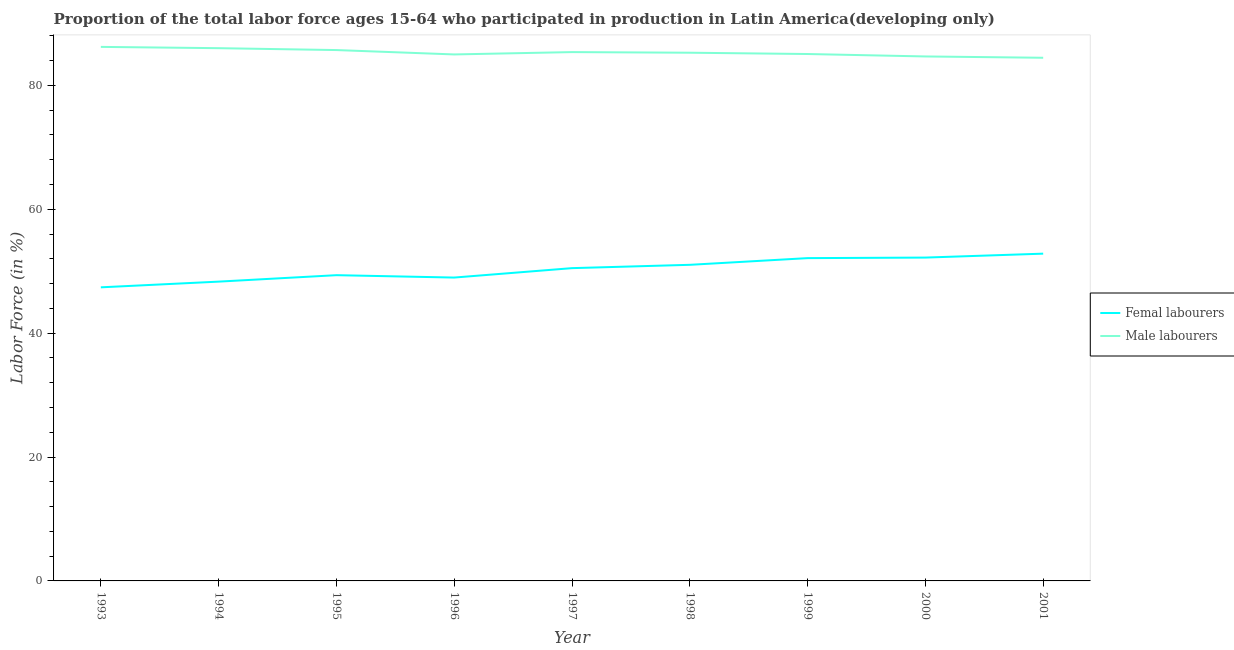How many different coloured lines are there?
Your answer should be very brief. 2. Is the number of lines equal to the number of legend labels?
Give a very brief answer. Yes. What is the percentage of male labour force in 2000?
Offer a very short reply. 84.67. Across all years, what is the maximum percentage of male labour force?
Your response must be concise. 86.21. Across all years, what is the minimum percentage of male labour force?
Ensure brevity in your answer.  84.46. What is the total percentage of female labor force in the graph?
Make the answer very short. 452.73. What is the difference between the percentage of female labor force in 1996 and that in 1998?
Your answer should be very brief. -2.06. What is the difference between the percentage of female labor force in 1998 and the percentage of male labour force in 2000?
Ensure brevity in your answer.  -33.64. What is the average percentage of male labour force per year?
Keep it short and to the point. 85.31. In the year 2001, what is the difference between the percentage of male labour force and percentage of female labor force?
Offer a very short reply. 31.62. In how many years, is the percentage of female labor force greater than 48 %?
Provide a short and direct response. 8. What is the ratio of the percentage of male labour force in 1996 to that in 1997?
Your answer should be very brief. 1. Is the difference between the percentage of female labor force in 1997 and 2001 greater than the difference between the percentage of male labour force in 1997 and 2001?
Your answer should be compact. No. What is the difference between the highest and the second highest percentage of male labour force?
Provide a succinct answer. 0.21. What is the difference between the highest and the lowest percentage of female labor force?
Provide a succinct answer. 5.44. Does the percentage of female labor force monotonically increase over the years?
Provide a short and direct response. No. Is the percentage of female labor force strictly less than the percentage of male labour force over the years?
Make the answer very short. Yes. Does the graph contain any zero values?
Your answer should be very brief. No. Does the graph contain grids?
Offer a very short reply. No. Where does the legend appear in the graph?
Keep it short and to the point. Center right. How are the legend labels stacked?
Your answer should be compact. Vertical. What is the title of the graph?
Ensure brevity in your answer.  Proportion of the total labor force ages 15-64 who participated in production in Latin America(developing only). Does "Export" appear as one of the legend labels in the graph?
Provide a short and direct response. No. What is the label or title of the X-axis?
Make the answer very short. Year. What is the Labor Force (in %) of Femal labourers in 1993?
Offer a terse response. 47.4. What is the Labor Force (in %) of Male labourers in 1993?
Provide a succinct answer. 86.21. What is the Labor Force (in %) of Femal labourers in 1994?
Offer a very short reply. 48.32. What is the Labor Force (in %) in Male labourers in 1994?
Provide a short and direct response. 86.01. What is the Labor Force (in %) of Femal labourers in 1995?
Your answer should be compact. 49.36. What is the Labor Force (in %) in Male labourers in 1995?
Offer a very short reply. 85.7. What is the Labor Force (in %) of Femal labourers in 1996?
Offer a very short reply. 48.98. What is the Labor Force (in %) of Male labourers in 1996?
Your answer should be compact. 85. What is the Labor Force (in %) in Femal labourers in 1997?
Provide a succinct answer. 50.5. What is the Labor Force (in %) in Male labourers in 1997?
Keep it short and to the point. 85.37. What is the Labor Force (in %) of Femal labourers in 1998?
Give a very brief answer. 51.03. What is the Labor Force (in %) in Male labourers in 1998?
Offer a terse response. 85.28. What is the Labor Force (in %) of Femal labourers in 1999?
Your answer should be compact. 52.11. What is the Labor Force (in %) in Male labourers in 1999?
Provide a succinct answer. 85.06. What is the Labor Force (in %) in Femal labourers in 2000?
Give a very brief answer. 52.2. What is the Labor Force (in %) in Male labourers in 2000?
Your response must be concise. 84.67. What is the Labor Force (in %) of Femal labourers in 2001?
Your response must be concise. 52.83. What is the Labor Force (in %) of Male labourers in 2001?
Your answer should be compact. 84.46. Across all years, what is the maximum Labor Force (in %) of Femal labourers?
Provide a short and direct response. 52.83. Across all years, what is the maximum Labor Force (in %) in Male labourers?
Provide a short and direct response. 86.21. Across all years, what is the minimum Labor Force (in %) in Femal labourers?
Offer a very short reply. 47.4. Across all years, what is the minimum Labor Force (in %) of Male labourers?
Offer a very short reply. 84.46. What is the total Labor Force (in %) in Femal labourers in the graph?
Your answer should be very brief. 452.73. What is the total Labor Force (in %) in Male labourers in the graph?
Your response must be concise. 767.77. What is the difference between the Labor Force (in %) in Femal labourers in 1993 and that in 1994?
Ensure brevity in your answer.  -0.92. What is the difference between the Labor Force (in %) in Male labourers in 1993 and that in 1994?
Your response must be concise. 0.21. What is the difference between the Labor Force (in %) in Femal labourers in 1993 and that in 1995?
Provide a succinct answer. -1.96. What is the difference between the Labor Force (in %) of Male labourers in 1993 and that in 1995?
Provide a short and direct response. 0.51. What is the difference between the Labor Force (in %) of Femal labourers in 1993 and that in 1996?
Offer a very short reply. -1.58. What is the difference between the Labor Force (in %) in Male labourers in 1993 and that in 1996?
Offer a very short reply. 1.22. What is the difference between the Labor Force (in %) of Femal labourers in 1993 and that in 1997?
Provide a succinct answer. -3.1. What is the difference between the Labor Force (in %) of Male labourers in 1993 and that in 1997?
Your response must be concise. 0.84. What is the difference between the Labor Force (in %) of Femal labourers in 1993 and that in 1998?
Give a very brief answer. -3.63. What is the difference between the Labor Force (in %) of Male labourers in 1993 and that in 1998?
Offer a terse response. 0.94. What is the difference between the Labor Force (in %) of Femal labourers in 1993 and that in 1999?
Keep it short and to the point. -4.71. What is the difference between the Labor Force (in %) in Male labourers in 1993 and that in 1999?
Ensure brevity in your answer.  1.15. What is the difference between the Labor Force (in %) of Femal labourers in 1993 and that in 2000?
Make the answer very short. -4.8. What is the difference between the Labor Force (in %) in Male labourers in 1993 and that in 2000?
Your answer should be compact. 1.54. What is the difference between the Labor Force (in %) in Femal labourers in 1993 and that in 2001?
Your answer should be compact. -5.44. What is the difference between the Labor Force (in %) of Male labourers in 1993 and that in 2001?
Ensure brevity in your answer.  1.76. What is the difference between the Labor Force (in %) of Femal labourers in 1994 and that in 1995?
Provide a succinct answer. -1.04. What is the difference between the Labor Force (in %) in Male labourers in 1994 and that in 1995?
Offer a very short reply. 0.3. What is the difference between the Labor Force (in %) in Femal labourers in 1994 and that in 1996?
Offer a very short reply. -0.66. What is the difference between the Labor Force (in %) of Femal labourers in 1994 and that in 1997?
Keep it short and to the point. -2.18. What is the difference between the Labor Force (in %) of Male labourers in 1994 and that in 1997?
Your response must be concise. 0.63. What is the difference between the Labor Force (in %) in Femal labourers in 1994 and that in 1998?
Keep it short and to the point. -2.71. What is the difference between the Labor Force (in %) in Male labourers in 1994 and that in 1998?
Offer a very short reply. 0.73. What is the difference between the Labor Force (in %) of Femal labourers in 1994 and that in 1999?
Make the answer very short. -3.79. What is the difference between the Labor Force (in %) of Male labourers in 1994 and that in 1999?
Give a very brief answer. 0.94. What is the difference between the Labor Force (in %) of Femal labourers in 1994 and that in 2000?
Your answer should be very brief. -3.88. What is the difference between the Labor Force (in %) of Male labourers in 1994 and that in 2000?
Your response must be concise. 1.34. What is the difference between the Labor Force (in %) in Femal labourers in 1994 and that in 2001?
Your response must be concise. -4.51. What is the difference between the Labor Force (in %) in Male labourers in 1994 and that in 2001?
Make the answer very short. 1.55. What is the difference between the Labor Force (in %) in Femal labourers in 1995 and that in 1996?
Offer a very short reply. 0.38. What is the difference between the Labor Force (in %) of Male labourers in 1995 and that in 1996?
Provide a short and direct response. 0.71. What is the difference between the Labor Force (in %) in Femal labourers in 1995 and that in 1997?
Offer a terse response. -1.14. What is the difference between the Labor Force (in %) in Male labourers in 1995 and that in 1997?
Make the answer very short. 0.33. What is the difference between the Labor Force (in %) of Femal labourers in 1995 and that in 1998?
Provide a short and direct response. -1.67. What is the difference between the Labor Force (in %) in Male labourers in 1995 and that in 1998?
Keep it short and to the point. 0.43. What is the difference between the Labor Force (in %) of Femal labourers in 1995 and that in 1999?
Your answer should be compact. -2.75. What is the difference between the Labor Force (in %) of Male labourers in 1995 and that in 1999?
Give a very brief answer. 0.64. What is the difference between the Labor Force (in %) of Femal labourers in 1995 and that in 2000?
Make the answer very short. -2.84. What is the difference between the Labor Force (in %) of Male labourers in 1995 and that in 2000?
Keep it short and to the point. 1.03. What is the difference between the Labor Force (in %) of Femal labourers in 1995 and that in 2001?
Keep it short and to the point. -3.47. What is the difference between the Labor Force (in %) in Male labourers in 1995 and that in 2001?
Provide a short and direct response. 1.24. What is the difference between the Labor Force (in %) of Femal labourers in 1996 and that in 1997?
Provide a short and direct response. -1.52. What is the difference between the Labor Force (in %) in Male labourers in 1996 and that in 1997?
Offer a terse response. -0.38. What is the difference between the Labor Force (in %) of Femal labourers in 1996 and that in 1998?
Keep it short and to the point. -2.06. What is the difference between the Labor Force (in %) of Male labourers in 1996 and that in 1998?
Your answer should be compact. -0.28. What is the difference between the Labor Force (in %) in Femal labourers in 1996 and that in 1999?
Give a very brief answer. -3.14. What is the difference between the Labor Force (in %) in Male labourers in 1996 and that in 1999?
Provide a short and direct response. -0.07. What is the difference between the Labor Force (in %) in Femal labourers in 1996 and that in 2000?
Keep it short and to the point. -3.23. What is the difference between the Labor Force (in %) in Male labourers in 1996 and that in 2000?
Provide a short and direct response. 0.33. What is the difference between the Labor Force (in %) of Femal labourers in 1996 and that in 2001?
Ensure brevity in your answer.  -3.86. What is the difference between the Labor Force (in %) in Male labourers in 1996 and that in 2001?
Offer a very short reply. 0.54. What is the difference between the Labor Force (in %) in Femal labourers in 1997 and that in 1998?
Ensure brevity in your answer.  -0.54. What is the difference between the Labor Force (in %) in Male labourers in 1997 and that in 1998?
Keep it short and to the point. 0.1. What is the difference between the Labor Force (in %) in Femal labourers in 1997 and that in 1999?
Offer a terse response. -1.62. What is the difference between the Labor Force (in %) in Male labourers in 1997 and that in 1999?
Keep it short and to the point. 0.31. What is the difference between the Labor Force (in %) of Femal labourers in 1997 and that in 2000?
Your answer should be very brief. -1.71. What is the difference between the Labor Force (in %) of Male labourers in 1997 and that in 2000?
Offer a very short reply. 0.7. What is the difference between the Labor Force (in %) in Femal labourers in 1997 and that in 2001?
Ensure brevity in your answer.  -2.34. What is the difference between the Labor Force (in %) of Male labourers in 1997 and that in 2001?
Offer a very short reply. 0.92. What is the difference between the Labor Force (in %) of Femal labourers in 1998 and that in 1999?
Your answer should be very brief. -1.08. What is the difference between the Labor Force (in %) of Male labourers in 1998 and that in 1999?
Your response must be concise. 0.21. What is the difference between the Labor Force (in %) in Femal labourers in 1998 and that in 2000?
Make the answer very short. -1.17. What is the difference between the Labor Force (in %) of Male labourers in 1998 and that in 2000?
Provide a succinct answer. 0.6. What is the difference between the Labor Force (in %) of Femal labourers in 1998 and that in 2001?
Keep it short and to the point. -1.8. What is the difference between the Labor Force (in %) in Male labourers in 1998 and that in 2001?
Offer a terse response. 0.82. What is the difference between the Labor Force (in %) in Femal labourers in 1999 and that in 2000?
Your response must be concise. -0.09. What is the difference between the Labor Force (in %) of Male labourers in 1999 and that in 2000?
Ensure brevity in your answer.  0.39. What is the difference between the Labor Force (in %) of Femal labourers in 1999 and that in 2001?
Make the answer very short. -0.72. What is the difference between the Labor Force (in %) of Male labourers in 1999 and that in 2001?
Make the answer very short. 0.61. What is the difference between the Labor Force (in %) of Femal labourers in 2000 and that in 2001?
Your answer should be very brief. -0.63. What is the difference between the Labor Force (in %) in Male labourers in 2000 and that in 2001?
Ensure brevity in your answer.  0.21. What is the difference between the Labor Force (in %) of Femal labourers in 1993 and the Labor Force (in %) of Male labourers in 1994?
Your answer should be compact. -38.61. What is the difference between the Labor Force (in %) in Femal labourers in 1993 and the Labor Force (in %) in Male labourers in 1995?
Your response must be concise. -38.3. What is the difference between the Labor Force (in %) in Femal labourers in 1993 and the Labor Force (in %) in Male labourers in 1996?
Provide a short and direct response. -37.6. What is the difference between the Labor Force (in %) in Femal labourers in 1993 and the Labor Force (in %) in Male labourers in 1997?
Provide a succinct answer. -37.98. What is the difference between the Labor Force (in %) of Femal labourers in 1993 and the Labor Force (in %) of Male labourers in 1998?
Give a very brief answer. -37.88. What is the difference between the Labor Force (in %) of Femal labourers in 1993 and the Labor Force (in %) of Male labourers in 1999?
Give a very brief answer. -37.66. What is the difference between the Labor Force (in %) of Femal labourers in 1993 and the Labor Force (in %) of Male labourers in 2000?
Your answer should be very brief. -37.27. What is the difference between the Labor Force (in %) in Femal labourers in 1993 and the Labor Force (in %) in Male labourers in 2001?
Provide a short and direct response. -37.06. What is the difference between the Labor Force (in %) in Femal labourers in 1994 and the Labor Force (in %) in Male labourers in 1995?
Provide a succinct answer. -37.38. What is the difference between the Labor Force (in %) in Femal labourers in 1994 and the Labor Force (in %) in Male labourers in 1996?
Your answer should be compact. -36.68. What is the difference between the Labor Force (in %) of Femal labourers in 1994 and the Labor Force (in %) of Male labourers in 1997?
Offer a terse response. -37.05. What is the difference between the Labor Force (in %) of Femal labourers in 1994 and the Labor Force (in %) of Male labourers in 1998?
Provide a succinct answer. -36.96. What is the difference between the Labor Force (in %) of Femal labourers in 1994 and the Labor Force (in %) of Male labourers in 1999?
Your answer should be very brief. -36.74. What is the difference between the Labor Force (in %) of Femal labourers in 1994 and the Labor Force (in %) of Male labourers in 2000?
Your response must be concise. -36.35. What is the difference between the Labor Force (in %) of Femal labourers in 1994 and the Labor Force (in %) of Male labourers in 2001?
Give a very brief answer. -36.14. What is the difference between the Labor Force (in %) in Femal labourers in 1995 and the Labor Force (in %) in Male labourers in 1996?
Your response must be concise. -35.64. What is the difference between the Labor Force (in %) of Femal labourers in 1995 and the Labor Force (in %) of Male labourers in 1997?
Offer a terse response. -36.01. What is the difference between the Labor Force (in %) of Femal labourers in 1995 and the Labor Force (in %) of Male labourers in 1998?
Keep it short and to the point. -35.92. What is the difference between the Labor Force (in %) of Femal labourers in 1995 and the Labor Force (in %) of Male labourers in 1999?
Your response must be concise. -35.7. What is the difference between the Labor Force (in %) in Femal labourers in 1995 and the Labor Force (in %) in Male labourers in 2000?
Ensure brevity in your answer.  -35.31. What is the difference between the Labor Force (in %) in Femal labourers in 1995 and the Labor Force (in %) in Male labourers in 2001?
Your answer should be compact. -35.1. What is the difference between the Labor Force (in %) of Femal labourers in 1996 and the Labor Force (in %) of Male labourers in 1997?
Your answer should be compact. -36.4. What is the difference between the Labor Force (in %) of Femal labourers in 1996 and the Labor Force (in %) of Male labourers in 1998?
Your answer should be very brief. -36.3. What is the difference between the Labor Force (in %) in Femal labourers in 1996 and the Labor Force (in %) in Male labourers in 1999?
Give a very brief answer. -36.09. What is the difference between the Labor Force (in %) of Femal labourers in 1996 and the Labor Force (in %) of Male labourers in 2000?
Keep it short and to the point. -35.7. What is the difference between the Labor Force (in %) of Femal labourers in 1996 and the Labor Force (in %) of Male labourers in 2001?
Offer a very short reply. -35.48. What is the difference between the Labor Force (in %) in Femal labourers in 1997 and the Labor Force (in %) in Male labourers in 1998?
Keep it short and to the point. -34.78. What is the difference between the Labor Force (in %) of Femal labourers in 1997 and the Labor Force (in %) of Male labourers in 1999?
Provide a short and direct response. -34.57. What is the difference between the Labor Force (in %) of Femal labourers in 1997 and the Labor Force (in %) of Male labourers in 2000?
Make the answer very short. -34.18. What is the difference between the Labor Force (in %) of Femal labourers in 1997 and the Labor Force (in %) of Male labourers in 2001?
Give a very brief answer. -33.96. What is the difference between the Labor Force (in %) in Femal labourers in 1998 and the Labor Force (in %) in Male labourers in 1999?
Provide a short and direct response. -34.03. What is the difference between the Labor Force (in %) in Femal labourers in 1998 and the Labor Force (in %) in Male labourers in 2000?
Provide a short and direct response. -33.64. What is the difference between the Labor Force (in %) in Femal labourers in 1998 and the Labor Force (in %) in Male labourers in 2001?
Your answer should be compact. -33.43. What is the difference between the Labor Force (in %) in Femal labourers in 1999 and the Labor Force (in %) in Male labourers in 2000?
Make the answer very short. -32.56. What is the difference between the Labor Force (in %) in Femal labourers in 1999 and the Labor Force (in %) in Male labourers in 2001?
Offer a very short reply. -32.35. What is the difference between the Labor Force (in %) of Femal labourers in 2000 and the Labor Force (in %) of Male labourers in 2001?
Keep it short and to the point. -32.26. What is the average Labor Force (in %) of Femal labourers per year?
Make the answer very short. 50.3. What is the average Labor Force (in %) in Male labourers per year?
Offer a very short reply. 85.31. In the year 1993, what is the difference between the Labor Force (in %) in Femal labourers and Labor Force (in %) in Male labourers?
Your answer should be compact. -38.82. In the year 1994, what is the difference between the Labor Force (in %) of Femal labourers and Labor Force (in %) of Male labourers?
Your answer should be very brief. -37.69. In the year 1995, what is the difference between the Labor Force (in %) of Femal labourers and Labor Force (in %) of Male labourers?
Provide a succinct answer. -36.34. In the year 1996, what is the difference between the Labor Force (in %) of Femal labourers and Labor Force (in %) of Male labourers?
Provide a succinct answer. -36.02. In the year 1997, what is the difference between the Labor Force (in %) of Femal labourers and Labor Force (in %) of Male labourers?
Provide a succinct answer. -34.88. In the year 1998, what is the difference between the Labor Force (in %) of Femal labourers and Labor Force (in %) of Male labourers?
Make the answer very short. -34.24. In the year 1999, what is the difference between the Labor Force (in %) of Femal labourers and Labor Force (in %) of Male labourers?
Keep it short and to the point. -32.95. In the year 2000, what is the difference between the Labor Force (in %) in Femal labourers and Labor Force (in %) in Male labourers?
Your answer should be very brief. -32.47. In the year 2001, what is the difference between the Labor Force (in %) of Femal labourers and Labor Force (in %) of Male labourers?
Keep it short and to the point. -31.62. What is the ratio of the Labor Force (in %) in Femal labourers in 1993 to that in 1994?
Your answer should be very brief. 0.98. What is the ratio of the Labor Force (in %) in Male labourers in 1993 to that in 1994?
Make the answer very short. 1. What is the ratio of the Labor Force (in %) in Femal labourers in 1993 to that in 1995?
Your answer should be compact. 0.96. What is the ratio of the Labor Force (in %) of Male labourers in 1993 to that in 1995?
Offer a terse response. 1.01. What is the ratio of the Labor Force (in %) in Femal labourers in 1993 to that in 1996?
Your answer should be compact. 0.97. What is the ratio of the Labor Force (in %) in Male labourers in 1993 to that in 1996?
Ensure brevity in your answer.  1.01. What is the ratio of the Labor Force (in %) of Femal labourers in 1993 to that in 1997?
Offer a terse response. 0.94. What is the ratio of the Labor Force (in %) in Male labourers in 1993 to that in 1997?
Provide a short and direct response. 1.01. What is the ratio of the Labor Force (in %) in Femal labourers in 1993 to that in 1998?
Make the answer very short. 0.93. What is the ratio of the Labor Force (in %) of Femal labourers in 1993 to that in 1999?
Your answer should be very brief. 0.91. What is the ratio of the Labor Force (in %) of Male labourers in 1993 to that in 1999?
Ensure brevity in your answer.  1.01. What is the ratio of the Labor Force (in %) in Femal labourers in 1993 to that in 2000?
Make the answer very short. 0.91. What is the ratio of the Labor Force (in %) in Male labourers in 1993 to that in 2000?
Offer a very short reply. 1.02. What is the ratio of the Labor Force (in %) of Femal labourers in 1993 to that in 2001?
Keep it short and to the point. 0.9. What is the ratio of the Labor Force (in %) in Male labourers in 1993 to that in 2001?
Give a very brief answer. 1.02. What is the ratio of the Labor Force (in %) in Femal labourers in 1994 to that in 1995?
Provide a succinct answer. 0.98. What is the ratio of the Labor Force (in %) in Femal labourers in 1994 to that in 1996?
Make the answer very short. 0.99. What is the ratio of the Labor Force (in %) of Male labourers in 1994 to that in 1996?
Your answer should be compact. 1.01. What is the ratio of the Labor Force (in %) in Femal labourers in 1994 to that in 1997?
Give a very brief answer. 0.96. What is the ratio of the Labor Force (in %) in Male labourers in 1994 to that in 1997?
Offer a terse response. 1.01. What is the ratio of the Labor Force (in %) of Femal labourers in 1994 to that in 1998?
Your answer should be very brief. 0.95. What is the ratio of the Labor Force (in %) of Male labourers in 1994 to that in 1998?
Your response must be concise. 1.01. What is the ratio of the Labor Force (in %) in Femal labourers in 1994 to that in 1999?
Your response must be concise. 0.93. What is the ratio of the Labor Force (in %) in Male labourers in 1994 to that in 1999?
Your answer should be very brief. 1.01. What is the ratio of the Labor Force (in %) of Femal labourers in 1994 to that in 2000?
Your response must be concise. 0.93. What is the ratio of the Labor Force (in %) in Male labourers in 1994 to that in 2000?
Offer a very short reply. 1.02. What is the ratio of the Labor Force (in %) of Femal labourers in 1994 to that in 2001?
Give a very brief answer. 0.91. What is the ratio of the Labor Force (in %) in Male labourers in 1994 to that in 2001?
Keep it short and to the point. 1.02. What is the ratio of the Labor Force (in %) of Femal labourers in 1995 to that in 1996?
Provide a succinct answer. 1.01. What is the ratio of the Labor Force (in %) in Male labourers in 1995 to that in 1996?
Keep it short and to the point. 1.01. What is the ratio of the Labor Force (in %) of Femal labourers in 1995 to that in 1997?
Keep it short and to the point. 0.98. What is the ratio of the Labor Force (in %) of Femal labourers in 1995 to that in 1998?
Your response must be concise. 0.97. What is the ratio of the Labor Force (in %) in Femal labourers in 1995 to that in 1999?
Keep it short and to the point. 0.95. What is the ratio of the Labor Force (in %) in Male labourers in 1995 to that in 1999?
Your answer should be very brief. 1.01. What is the ratio of the Labor Force (in %) of Femal labourers in 1995 to that in 2000?
Give a very brief answer. 0.95. What is the ratio of the Labor Force (in %) of Male labourers in 1995 to that in 2000?
Provide a succinct answer. 1.01. What is the ratio of the Labor Force (in %) in Femal labourers in 1995 to that in 2001?
Your answer should be compact. 0.93. What is the ratio of the Labor Force (in %) in Male labourers in 1995 to that in 2001?
Keep it short and to the point. 1.01. What is the ratio of the Labor Force (in %) of Femal labourers in 1996 to that in 1997?
Ensure brevity in your answer.  0.97. What is the ratio of the Labor Force (in %) of Femal labourers in 1996 to that in 1998?
Your answer should be very brief. 0.96. What is the ratio of the Labor Force (in %) of Male labourers in 1996 to that in 1998?
Offer a terse response. 1. What is the ratio of the Labor Force (in %) in Femal labourers in 1996 to that in 1999?
Your response must be concise. 0.94. What is the ratio of the Labor Force (in %) in Male labourers in 1996 to that in 1999?
Make the answer very short. 1. What is the ratio of the Labor Force (in %) of Femal labourers in 1996 to that in 2000?
Give a very brief answer. 0.94. What is the ratio of the Labor Force (in %) in Femal labourers in 1996 to that in 2001?
Make the answer very short. 0.93. What is the ratio of the Labor Force (in %) in Male labourers in 1996 to that in 2001?
Offer a terse response. 1.01. What is the ratio of the Labor Force (in %) in Femal labourers in 1997 to that in 1998?
Your answer should be very brief. 0.99. What is the ratio of the Labor Force (in %) in Femal labourers in 1997 to that in 2000?
Ensure brevity in your answer.  0.97. What is the ratio of the Labor Force (in %) in Male labourers in 1997 to that in 2000?
Your answer should be compact. 1.01. What is the ratio of the Labor Force (in %) of Femal labourers in 1997 to that in 2001?
Keep it short and to the point. 0.96. What is the ratio of the Labor Force (in %) in Male labourers in 1997 to that in 2001?
Provide a short and direct response. 1.01. What is the ratio of the Labor Force (in %) in Femal labourers in 1998 to that in 1999?
Provide a succinct answer. 0.98. What is the ratio of the Labor Force (in %) of Male labourers in 1998 to that in 1999?
Your response must be concise. 1. What is the ratio of the Labor Force (in %) in Femal labourers in 1998 to that in 2000?
Provide a short and direct response. 0.98. What is the ratio of the Labor Force (in %) of Male labourers in 1998 to that in 2000?
Offer a terse response. 1.01. What is the ratio of the Labor Force (in %) in Femal labourers in 1998 to that in 2001?
Offer a terse response. 0.97. What is the ratio of the Labor Force (in %) in Male labourers in 1998 to that in 2001?
Offer a very short reply. 1.01. What is the ratio of the Labor Force (in %) of Femal labourers in 1999 to that in 2001?
Offer a terse response. 0.99. What is the difference between the highest and the second highest Labor Force (in %) in Femal labourers?
Make the answer very short. 0.63. What is the difference between the highest and the second highest Labor Force (in %) in Male labourers?
Offer a very short reply. 0.21. What is the difference between the highest and the lowest Labor Force (in %) of Femal labourers?
Your response must be concise. 5.44. What is the difference between the highest and the lowest Labor Force (in %) in Male labourers?
Provide a succinct answer. 1.76. 